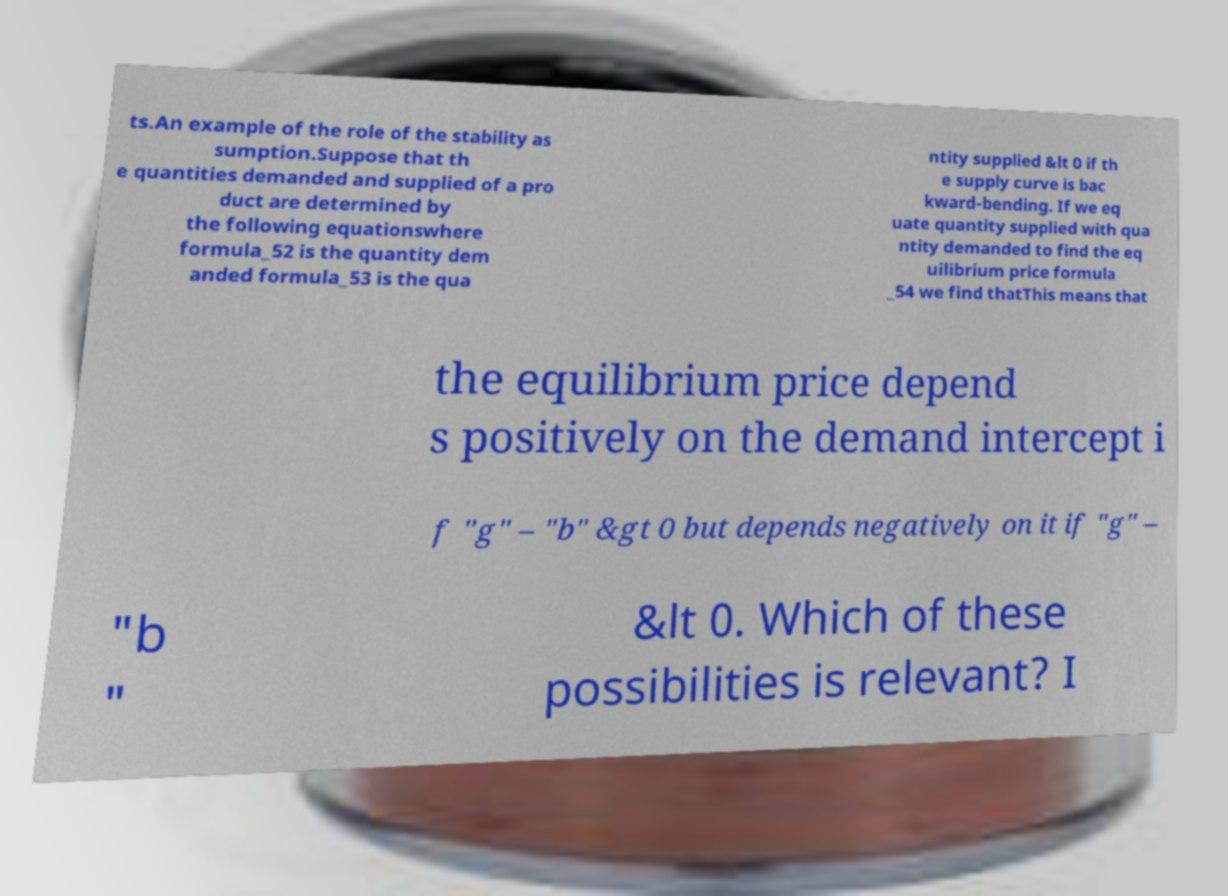Please identify and transcribe the text found in this image. ts.An example of the role of the stability as sumption.Suppose that th e quantities demanded and supplied of a pro duct are determined by the following equationswhere formula_52 is the quantity dem anded formula_53 is the qua ntity supplied &lt 0 if th e supply curve is bac kward-bending. If we eq uate quantity supplied with qua ntity demanded to find the eq uilibrium price formula _54 we find thatThis means that the equilibrium price depend s positively on the demand intercept i f "g" – "b" &gt 0 but depends negatively on it if "g" – "b " &lt 0. Which of these possibilities is relevant? I 